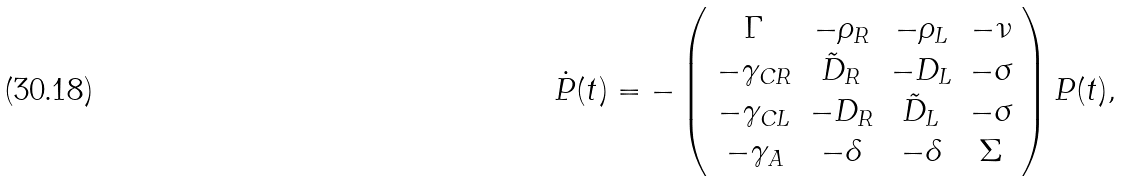<formula> <loc_0><loc_0><loc_500><loc_500>\dot { P } ( t ) = - \left ( \begin{array} { c c c c } \Gamma & - \rho _ { R } & - \rho _ { L } & - \nu \\ - \gamma _ { C R } & \tilde { D } _ { R } & - D _ { L } & - \sigma \\ - \gamma _ { C L } & - D _ { R } & \tilde { D } _ { L } & - \sigma \\ - \gamma _ { A } & - \delta & - \delta & \Sigma \end{array} \right ) P ( t ) ,</formula> 